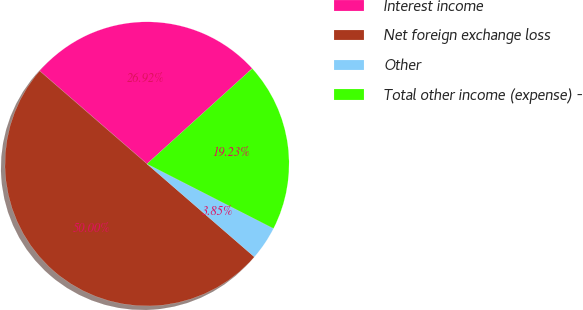Convert chart to OTSL. <chart><loc_0><loc_0><loc_500><loc_500><pie_chart><fcel>Interest income<fcel>Net foreign exchange loss<fcel>Other<fcel>Total other income (expense) -<nl><fcel>26.92%<fcel>50.0%<fcel>3.85%<fcel>19.23%<nl></chart> 